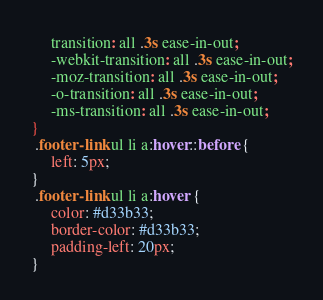Convert code to text. <code><loc_0><loc_0><loc_500><loc_500><_CSS_>     transition: all .3s ease-in-out;
     -webkit-transition: all .3s ease-in-out;
     -moz-transition: all .3s ease-in-out;
     -o-transition: all .3s ease-in-out;
     -ms-transition: all .3s ease-in-out;
}
 .footer-link ul li a:hover::before {
     left: 5px;
}
 .footer-link ul li a:hover {
     color: #d33b33;
     border-color: #d33b33;
     padding-left: 20px;
}</code> 